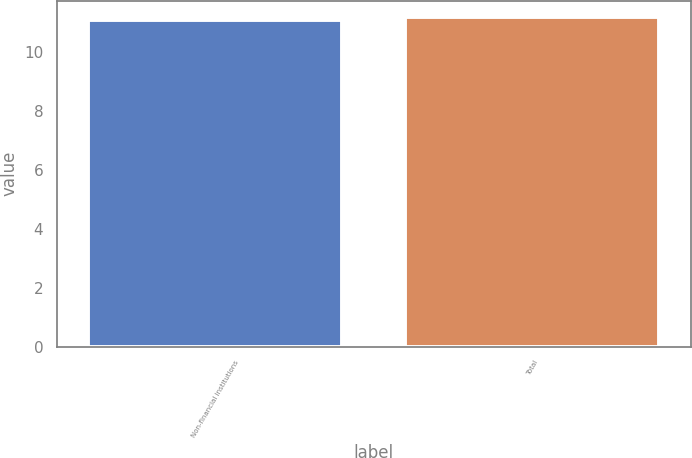<chart> <loc_0><loc_0><loc_500><loc_500><bar_chart><fcel>Non-financial institutions<fcel>Total<nl><fcel>11.1<fcel>11.2<nl></chart> 